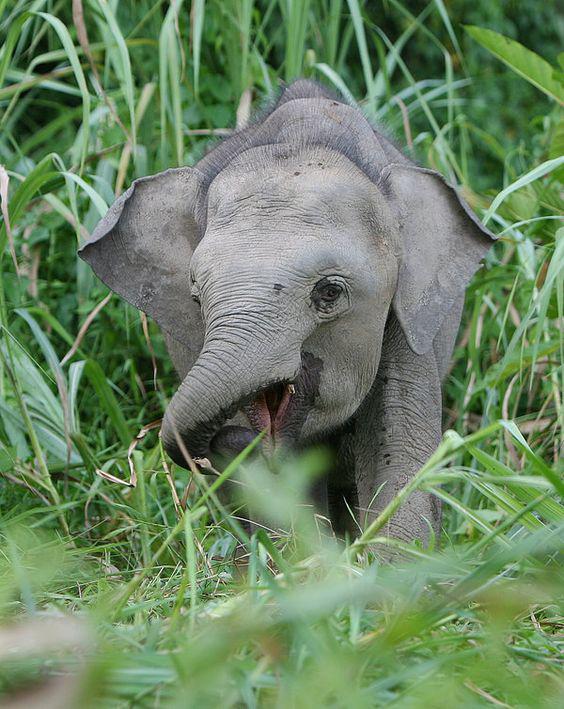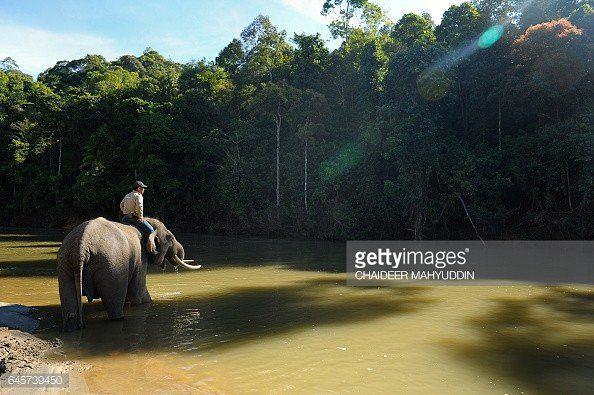The first image is the image on the left, the second image is the image on the right. For the images shown, is this caption "A small white bird with a long beak appears in one image standing near at least one elephant." true? Answer yes or no. No. The first image is the image on the left, the second image is the image on the right. Given the left and right images, does the statement "An image shows at least one elephant with feet in the water." hold true? Answer yes or no. Yes. 